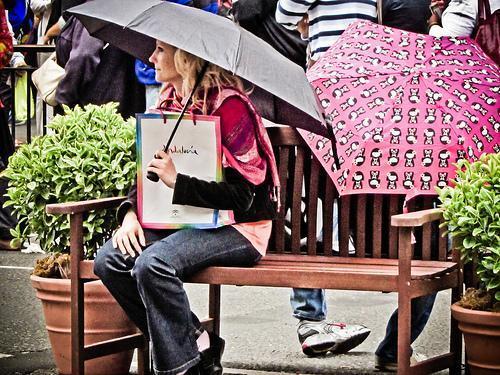How many open umbrellas are there?
Give a very brief answer. 2. 